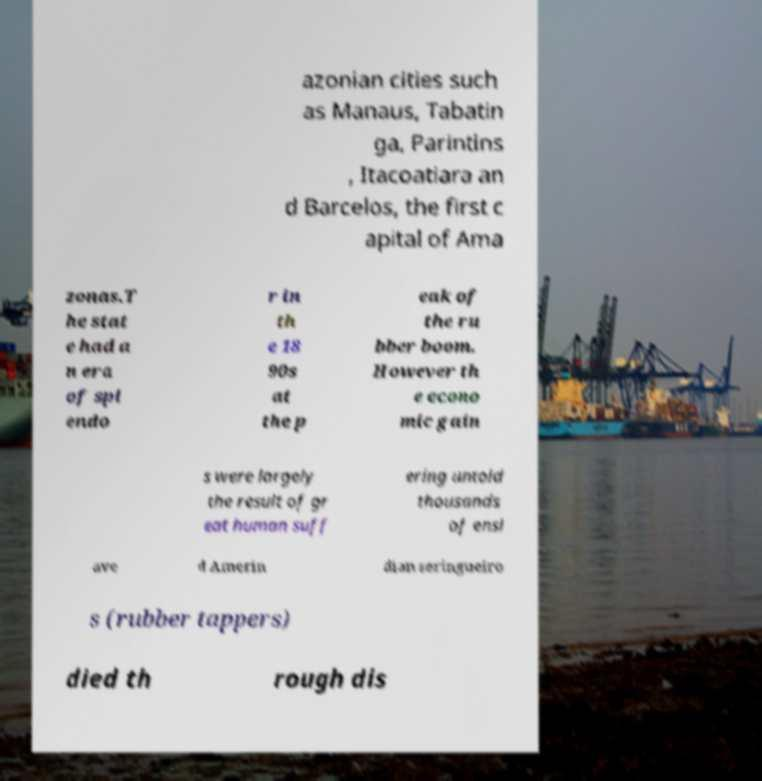Could you assist in decoding the text presented in this image and type it out clearly? azonian cities such as Manaus, Tabatin ga, Parintins , Itacoatiara an d Barcelos, the first c apital of Ama zonas.T he stat e had a n era of spl endo r in th e 18 90s at the p eak of the ru bber boom. However th e econo mic gain s were largely the result of gr eat human suff ering untold thousands of ensl ave d Amerin dian seringueiro s (rubber tappers) died th rough dis 